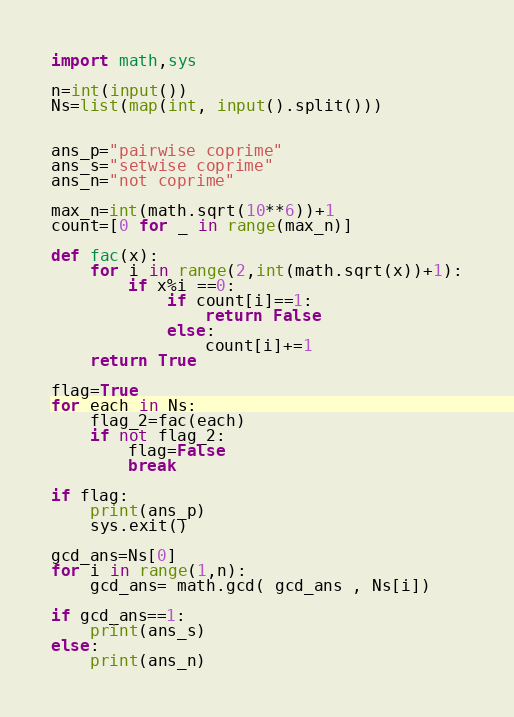<code> <loc_0><loc_0><loc_500><loc_500><_Python_>import math,sys

n=int(input())
Ns=list(map(int, input().split()))


ans_p="pairwise coprime"
ans_s="setwise coprime"
ans_n="not coprime"

max_n=int(math.sqrt(10**6))+1
count=[0 for _ in range(max_n)]

def fac(x):
    for i in range(2,int(math.sqrt(x))+1):
        if x%i ==0:
            if count[i]==1:
                return False
            else:
                count[i]+=1
    return True

flag=True
for each in Ns:
    flag_2=fac(each)
    if not flag_2:
        flag=False
        break

if flag:
    print(ans_p)
    sys.exit()

gcd_ans=Ns[0]
for i in range(1,n):
    gcd_ans= math.gcd( gcd_ans , Ns[i])

if gcd_ans==1:
    print(ans_s)
else:
    print(ans_n)</code> 